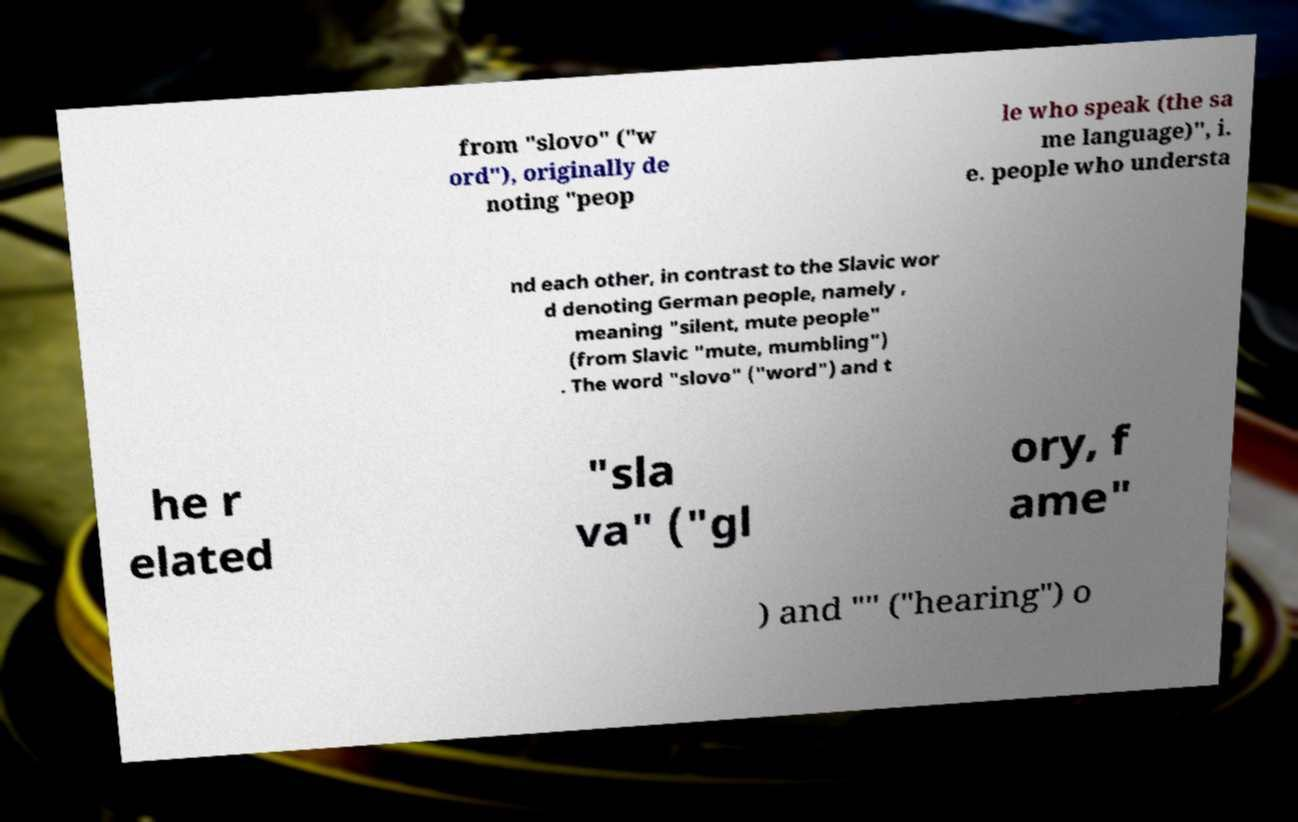Could you assist in decoding the text presented in this image and type it out clearly? from "slovo" ("w ord"), originally de noting "peop le who speak (the sa me language)", i. e. people who understa nd each other, in contrast to the Slavic wor d denoting German people, namely , meaning "silent, mute people" (from Slavic "mute, mumbling") . The word "slovo" ("word") and t he r elated "sla va" ("gl ory, f ame" ) and "" ("hearing") o 